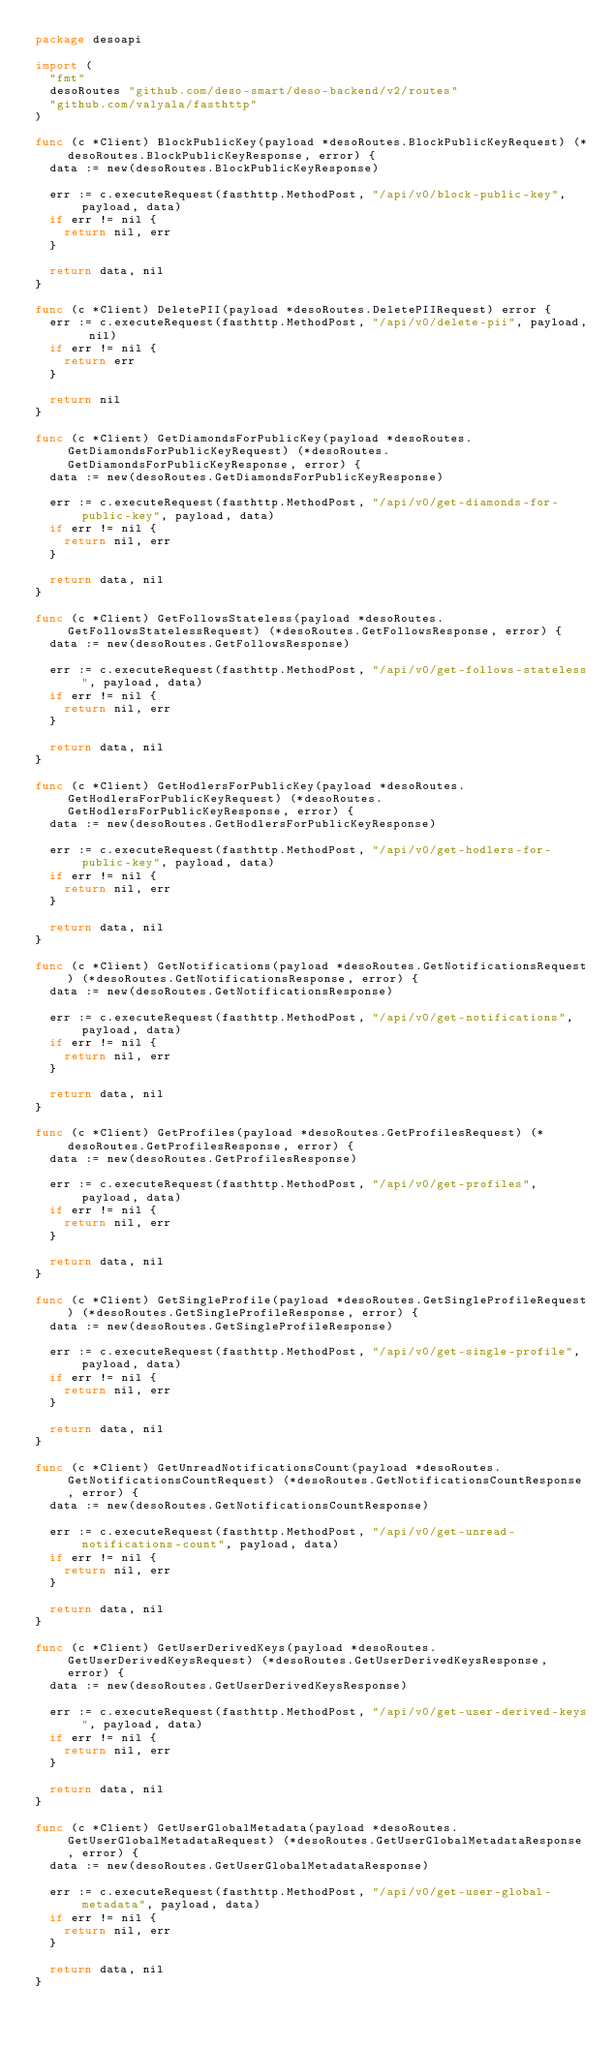<code> <loc_0><loc_0><loc_500><loc_500><_Go_>package desoapi

import (
	"fmt"
	desoRoutes "github.com/deso-smart/deso-backend/v2/routes"
	"github.com/valyala/fasthttp"
)

func (c *Client) BlockPublicKey(payload *desoRoutes.BlockPublicKeyRequest) (*desoRoutes.BlockPublicKeyResponse, error) {
	data := new(desoRoutes.BlockPublicKeyResponse)

	err := c.executeRequest(fasthttp.MethodPost, "/api/v0/block-public-key", payload, data)
	if err != nil {
		return nil, err
	}

	return data, nil
}

func (c *Client) DeletePII(payload *desoRoutes.DeletePIIRequest) error {
	err := c.executeRequest(fasthttp.MethodPost, "/api/v0/delete-pii", payload, nil)
	if err != nil {
		return err
	}

	return nil
}

func (c *Client) GetDiamondsForPublicKey(payload *desoRoutes.GetDiamondsForPublicKeyRequest) (*desoRoutes.GetDiamondsForPublicKeyResponse, error) {
	data := new(desoRoutes.GetDiamondsForPublicKeyResponse)

	err := c.executeRequest(fasthttp.MethodPost, "/api/v0/get-diamonds-for-public-key", payload, data)
	if err != nil {
		return nil, err
	}

	return data, nil
}

func (c *Client) GetFollowsStateless(payload *desoRoutes.GetFollowsStatelessRequest) (*desoRoutes.GetFollowsResponse, error) {
	data := new(desoRoutes.GetFollowsResponse)

	err := c.executeRequest(fasthttp.MethodPost, "/api/v0/get-follows-stateless", payload, data)
	if err != nil {
		return nil, err
	}

	return data, nil
}

func (c *Client) GetHodlersForPublicKey(payload *desoRoutes.GetHodlersForPublicKeyRequest) (*desoRoutes.GetHodlersForPublicKeyResponse, error) {
	data := new(desoRoutes.GetHodlersForPublicKeyResponse)

	err := c.executeRequest(fasthttp.MethodPost, "/api/v0/get-hodlers-for-public-key", payload, data)
	if err != nil {
		return nil, err
	}

	return data, nil
}

func (c *Client) GetNotifications(payload *desoRoutes.GetNotificationsRequest) (*desoRoutes.GetNotificationsResponse, error) {
	data := new(desoRoutes.GetNotificationsResponse)

	err := c.executeRequest(fasthttp.MethodPost, "/api/v0/get-notifications", payload, data)
	if err != nil {
		return nil, err
	}

	return data, nil
}

func (c *Client) GetProfiles(payload *desoRoutes.GetProfilesRequest) (*desoRoutes.GetProfilesResponse, error) {
	data := new(desoRoutes.GetProfilesResponse)

	err := c.executeRequest(fasthttp.MethodPost, "/api/v0/get-profiles", payload, data)
	if err != nil {
		return nil, err
	}

	return data, nil
}

func (c *Client) GetSingleProfile(payload *desoRoutes.GetSingleProfileRequest) (*desoRoutes.GetSingleProfileResponse, error) {
	data := new(desoRoutes.GetSingleProfileResponse)

	err := c.executeRequest(fasthttp.MethodPost, "/api/v0/get-single-profile", payload, data)
	if err != nil {
		return nil, err
	}

	return data, nil
}

func (c *Client) GetUnreadNotificationsCount(payload *desoRoutes.GetNotificationsCountRequest) (*desoRoutes.GetNotificationsCountResponse, error) {
	data := new(desoRoutes.GetNotificationsCountResponse)

	err := c.executeRequest(fasthttp.MethodPost, "/api/v0/get-unread-notifications-count", payload, data)
	if err != nil {
		return nil, err
	}

	return data, nil
}

func (c *Client) GetUserDerivedKeys(payload *desoRoutes.GetUserDerivedKeysRequest) (*desoRoutes.GetUserDerivedKeysResponse, error) {
	data := new(desoRoutes.GetUserDerivedKeysResponse)

	err := c.executeRequest(fasthttp.MethodPost, "/api/v0/get-user-derived-keys", payload, data)
	if err != nil {
		return nil, err
	}

	return data, nil
}

func (c *Client) GetUserGlobalMetadata(payload *desoRoutes.GetUserGlobalMetadataRequest) (*desoRoutes.GetUserGlobalMetadataResponse, error) {
	data := new(desoRoutes.GetUserGlobalMetadataResponse)

	err := c.executeRequest(fasthttp.MethodPost, "/api/v0/get-user-global-metadata", payload, data)
	if err != nil {
		return nil, err
	}

	return data, nil
}
</code> 